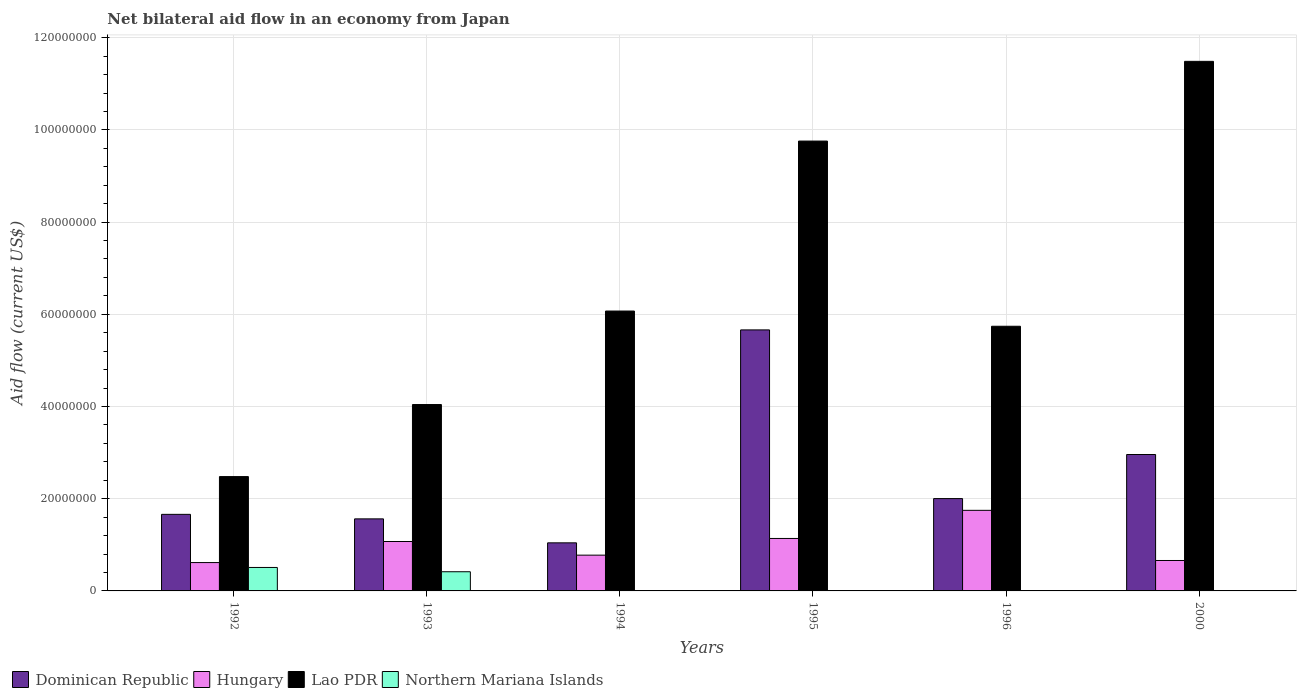How many different coloured bars are there?
Give a very brief answer. 4. How many groups of bars are there?
Ensure brevity in your answer.  6. Are the number of bars on each tick of the X-axis equal?
Ensure brevity in your answer.  No. In how many cases, is the number of bars for a given year not equal to the number of legend labels?
Your answer should be very brief. 2. Across all years, what is the maximum net bilateral aid flow in Northern Mariana Islands?
Ensure brevity in your answer.  5.09e+06. Across all years, what is the minimum net bilateral aid flow in Dominican Republic?
Ensure brevity in your answer.  1.04e+07. What is the total net bilateral aid flow in Northern Mariana Islands in the graph?
Provide a short and direct response. 9.27e+06. What is the difference between the net bilateral aid flow in Hungary in 1992 and that in 1995?
Ensure brevity in your answer.  -5.23e+06. What is the difference between the net bilateral aid flow in Lao PDR in 1994 and the net bilateral aid flow in Northern Mariana Islands in 1995?
Provide a short and direct response. 6.07e+07. What is the average net bilateral aid flow in Lao PDR per year?
Give a very brief answer. 6.60e+07. In the year 1993, what is the difference between the net bilateral aid flow in Lao PDR and net bilateral aid flow in Hungary?
Give a very brief answer. 2.97e+07. In how many years, is the net bilateral aid flow in Hungary greater than 80000000 US$?
Your answer should be very brief. 0. What is the ratio of the net bilateral aid flow in Dominican Republic in 1992 to that in 1993?
Keep it short and to the point. 1.06. Is the difference between the net bilateral aid flow in Lao PDR in 1993 and 1996 greater than the difference between the net bilateral aid flow in Hungary in 1993 and 1996?
Keep it short and to the point. No. What is the difference between the highest and the second highest net bilateral aid flow in Northern Mariana Islands?
Keep it short and to the point. 9.30e+05. What is the difference between the highest and the lowest net bilateral aid flow in Lao PDR?
Give a very brief answer. 9.01e+07. Is it the case that in every year, the sum of the net bilateral aid flow in Dominican Republic and net bilateral aid flow in Hungary is greater than the net bilateral aid flow in Lao PDR?
Provide a succinct answer. No. What is the difference between two consecutive major ticks on the Y-axis?
Provide a short and direct response. 2.00e+07. Are the values on the major ticks of Y-axis written in scientific E-notation?
Your answer should be compact. No. Does the graph contain any zero values?
Ensure brevity in your answer.  Yes. Does the graph contain grids?
Your answer should be very brief. Yes. Where does the legend appear in the graph?
Your answer should be compact. Bottom left. What is the title of the graph?
Give a very brief answer. Net bilateral aid flow in an economy from Japan. Does "Pakistan" appear as one of the legend labels in the graph?
Offer a terse response. No. What is the label or title of the X-axis?
Provide a succinct answer. Years. What is the label or title of the Y-axis?
Provide a short and direct response. Aid flow (current US$). What is the Aid flow (current US$) in Dominican Republic in 1992?
Your answer should be very brief. 1.66e+07. What is the Aid flow (current US$) in Hungary in 1992?
Give a very brief answer. 6.15e+06. What is the Aid flow (current US$) in Lao PDR in 1992?
Provide a succinct answer. 2.48e+07. What is the Aid flow (current US$) of Northern Mariana Islands in 1992?
Provide a short and direct response. 5.09e+06. What is the Aid flow (current US$) of Dominican Republic in 1993?
Give a very brief answer. 1.56e+07. What is the Aid flow (current US$) of Hungary in 1993?
Offer a very short reply. 1.07e+07. What is the Aid flow (current US$) of Lao PDR in 1993?
Give a very brief answer. 4.04e+07. What is the Aid flow (current US$) in Northern Mariana Islands in 1993?
Offer a very short reply. 4.16e+06. What is the Aid flow (current US$) in Dominican Republic in 1994?
Your answer should be very brief. 1.04e+07. What is the Aid flow (current US$) in Hungary in 1994?
Give a very brief answer. 7.76e+06. What is the Aid flow (current US$) of Lao PDR in 1994?
Provide a short and direct response. 6.07e+07. What is the Aid flow (current US$) of Dominican Republic in 1995?
Ensure brevity in your answer.  5.66e+07. What is the Aid flow (current US$) of Hungary in 1995?
Give a very brief answer. 1.14e+07. What is the Aid flow (current US$) of Lao PDR in 1995?
Offer a terse response. 9.76e+07. What is the Aid flow (current US$) in Dominican Republic in 1996?
Provide a short and direct response. 2.00e+07. What is the Aid flow (current US$) in Hungary in 1996?
Offer a terse response. 1.75e+07. What is the Aid flow (current US$) of Lao PDR in 1996?
Make the answer very short. 5.74e+07. What is the Aid flow (current US$) in Dominican Republic in 2000?
Your answer should be compact. 2.96e+07. What is the Aid flow (current US$) of Hungary in 2000?
Provide a short and direct response. 6.60e+06. What is the Aid flow (current US$) of Lao PDR in 2000?
Offer a terse response. 1.15e+08. What is the Aid flow (current US$) in Northern Mariana Islands in 2000?
Give a very brief answer. 10000. Across all years, what is the maximum Aid flow (current US$) in Dominican Republic?
Provide a short and direct response. 5.66e+07. Across all years, what is the maximum Aid flow (current US$) in Hungary?
Keep it short and to the point. 1.75e+07. Across all years, what is the maximum Aid flow (current US$) of Lao PDR?
Offer a terse response. 1.15e+08. Across all years, what is the maximum Aid flow (current US$) of Northern Mariana Islands?
Give a very brief answer. 5.09e+06. Across all years, what is the minimum Aid flow (current US$) of Dominican Republic?
Your answer should be very brief. 1.04e+07. Across all years, what is the minimum Aid flow (current US$) of Hungary?
Keep it short and to the point. 6.15e+06. Across all years, what is the minimum Aid flow (current US$) of Lao PDR?
Offer a very short reply. 2.48e+07. Across all years, what is the minimum Aid flow (current US$) in Northern Mariana Islands?
Your answer should be compact. 0. What is the total Aid flow (current US$) in Dominican Republic in the graph?
Provide a short and direct response. 1.49e+08. What is the total Aid flow (current US$) of Hungary in the graph?
Ensure brevity in your answer.  6.01e+07. What is the total Aid flow (current US$) in Lao PDR in the graph?
Offer a terse response. 3.96e+08. What is the total Aid flow (current US$) of Northern Mariana Islands in the graph?
Offer a very short reply. 9.27e+06. What is the difference between the Aid flow (current US$) in Dominican Republic in 1992 and that in 1993?
Ensure brevity in your answer.  9.80e+05. What is the difference between the Aid flow (current US$) of Hungary in 1992 and that in 1993?
Provide a short and direct response. -4.57e+06. What is the difference between the Aid flow (current US$) in Lao PDR in 1992 and that in 1993?
Keep it short and to the point. -1.56e+07. What is the difference between the Aid flow (current US$) in Northern Mariana Islands in 1992 and that in 1993?
Make the answer very short. 9.30e+05. What is the difference between the Aid flow (current US$) in Dominican Republic in 1992 and that in 1994?
Provide a short and direct response. 6.18e+06. What is the difference between the Aid flow (current US$) of Hungary in 1992 and that in 1994?
Provide a short and direct response. -1.61e+06. What is the difference between the Aid flow (current US$) in Lao PDR in 1992 and that in 1994?
Your response must be concise. -3.59e+07. What is the difference between the Aid flow (current US$) in Northern Mariana Islands in 1992 and that in 1994?
Provide a short and direct response. 5.08e+06. What is the difference between the Aid flow (current US$) in Dominican Republic in 1992 and that in 1995?
Offer a terse response. -4.00e+07. What is the difference between the Aid flow (current US$) in Hungary in 1992 and that in 1995?
Keep it short and to the point. -5.23e+06. What is the difference between the Aid flow (current US$) in Lao PDR in 1992 and that in 1995?
Your answer should be compact. -7.28e+07. What is the difference between the Aid flow (current US$) of Dominican Republic in 1992 and that in 1996?
Keep it short and to the point. -3.42e+06. What is the difference between the Aid flow (current US$) in Hungary in 1992 and that in 1996?
Provide a succinct answer. -1.13e+07. What is the difference between the Aid flow (current US$) of Lao PDR in 1992 and that in 1996?
Provide a succinct answer. -3.26e+07. What is the difference between the Aid flow (current US$) of Dominican Republic in 1992 and that in 2000?
Ensure brevity in your answer.  -1.30e+07. What is the difference between the Aid flow (current US$) in Hungary in 1992 and that in 2000?
Offer a very short reply. -4.50e+05. What is the difference between the Aid flow (current US$) in Lao PDR in 1992 and that in 2000?
Make the answer very short. -9.01e+07. What is the difference between the Aid flow (current US$) in Northern Mariana Islands in 1992 and that in 2000?
Ensure brevity in your answer.  5.08e+06. What is the difference between the Aid flow (current US$) in Dominican Republic in 1993 and that in 1994?
Provide a short and direct response. 5.20e+06. What is the difference between the Aid flow (current US$) of Hungary in 1993 and that in 1994?
Offer a terse response. 2.96e+06. What is the difference between the Aid flow (current US$) in Lao PDR in 1993 and that in 1994?
Offer a terse response. -2.03e+07. What is the difference between the Aid flow (current US$) in Northern Mariana Islands in 1993 and that in 1994?
Make the answer very short. 4.15e+06. What is the difference between the Aid flow (current US$) in Dominican Republic in 1993 and that in 1995?
Your answer should be compact. -4.10e+07. What is the difference between the Aid flow (current US$) of Hungary in 1993 and that in 1995?
Provide a succinct answer. -6.60e+05. What is the difference between the Aid flow (current US$) in Lao PDR in 1993 and that in 1995?
Make the answer very short. -5.72e+07. What is the difference between the Aid flow (current US$) in Dominican Republic in 1993 and that in 1996?
Provide a short and direct response. -4.40e+06. What is the difference between the Aid flow (current US$) of Hungary in 1993 and that in 1996?
Ensure brevity in your answer.  -6.76e+06. What is the difference between the Aid flow (current US$) in Lao PDR in 1993 and that in 1996?
Your answer should be compact. -1.70e+07. What is the difference between the Aid flow (current US$) of Dominican Republic in 1993 and that in 2000?
Provide a short and direct response. -1.40e+07. What is the difference between the Aid flow (current US$) in Hungary in 1993 and that in 2000?
Your answer should be very brief. 4.12e+06. What is the difference between the Aid flow (current US$) of Lao PDR in 1993 and that in 2000?
Provide a short and direct response. -7.44e+07. What is the difference between the Aid flow (current US$) of Northern Mariana Islands in 1993 and that in 2000?
Make the answer very short. 4.15e+06. What is the difference between the Aid flow (current US$) in Dominican Republic in 1994 and that in 1995?
Offer a very short reply. -4.62e+07. What is the difference between the Aid flow (current US$) of Hungary in 1994 and that in 1995?
Provide a succinct answer. -3.62e+06. What is the difference between the Aid flow (current US$) in Lao PDR in 1994 and that in 1995?
Keep it short and to the point. -3.69e+07. What is the difference between the Aid flow (current US$) in Dominican Republic in 1994 and that in 1996?
Give a very brief answer. -9.60e+06. What is the difference between the Aid flow (current US$) of Hungary in 1994 and that in 1996?
Make the answer very short. -9.72e+06. What is the difference between the Aid flow (current US$) in Lao PDR in 1994 and that in 1996?
Provide a short and direct response. 3.30e+06. What is the difference between the Aid flow (current US$) of Dominican Republic in 1994 and that in 2000?
Offer a terse response. -1.92e+07. What is the difference between the Aid flow (current US$) in Hungary in 1994 and that in 2000?
Offer a very short reply. 1.16e+06. What is the difference between the Aid flow (current US$) of Lao PDR in 1994 and that in 2000?
Provide a short and direct response. -5.42e+07. What is the difference between the Aid flow (current US$) in Dominican Republic in 1995 and that in 1996?
Your response must be concise. 3.66e+07. What is the difference between the Aid flow (current US$) of Hungary in 1995 and that in 1996?
Your answer should be very brief. -6.10e+06. What is the difference between the Aid flow (current US$) in Lao PDR in 1995 and that in 1996?
Provide a short and direct response. 4.02e+07. What is the difference between the Aid flow (current US$) in Dominican Republic in 1995 and that in 2000?
Ensure brevity in your answer.  2.70e+07. What is the difference between the Aid flow (current US$) in Hungary in 1995 and that in 2000?
Provide a succinct answer. 4.78e+06. What is the difference between the Aid flow (current US$) of Lao PDR in 1995 and that in 2000?
Give a very brief answer. -1.73e+07. What is the difference between the Aid flow (current US$) in Dominican Republic in 1996 and that in 2000?
Offer a very short reply. -9.56e+06. What is the difference between the Aid flow (current US$) of Hungary in 1996 and that in 2000?
Your answer should be very brief. 1.09e+07. What is the difference between the Aid flow (current US$) of Lao PDR in 1996 and that in 2000?
Provide a succinct answer. -5.75e+07. What is the difference between the Aid flow (current US$) in Dominican Republic in 1992 and the Aid flow (current US$) in Hungary in 1993?
Keep it short and to the point. 5.89e+06. What is the difference between the Aid flow (current US$) of Dominican Republic in 1992 and the Aid flow (current US$) of Lao PDR in 1993?
Your answer should be compact. -2.38e+07. What is the difference between the Aid flow (current US$) in Dominican Republic in 1992 and the Aid flow (current US$) in Northern Mariana Islands in 1993?
Provide a succinct answer. 1.24e+07. What is the difference between the Aid flow (current US$) of Hungary in 1992 and the Aid flow (current US$) of Lao PDR in 1993?
Keep it short and to the point. -3.43e+07. What is the difference between the Aid flow (current US$) of Hungary in 1992 and the Aid flow (current US$) of Northern Mariana Islands in 1993?
Offer a very short reply. 1.99e+06. What is the difference between the Aid flow (current US$) of Lao PDR in 1992 and the Aid flow (current US$) of Northern Mariana Islands in 1993?
Offer a very short reply. 2.06e+07. What is the difference between the Aid flow (current US$) of Dominican Republic in 1992 and the Aid flow (current US$) of Hungary in 1994?
Make the answer very short. 8.85e+06. What is the difference between the Aid flow (current US$) of Dominican Republic in 1992 and the Aid flow (current US$) of Lao PDR in 1994?
Your answer should be very brief. -4.41e+07. What is the difference between the Aid flow (current US$) in Dominican Republic in 1992 and the Aid flow (current US$) in Northern Mariana Islands in 1994?
Make the answer very short. 1.66e+07. What is the difference between the Aid flow (current US$) of Hungary in 1992 and the Aid flow (current US$) of Lao PDR in 1994?
Give a very brief answer. -5.46e+07. What is the difference between the Aid flow (current US$) of Hungary in 1992 and the Aid flow (current US$) of Northern Mariana Islands in 1994?
Offer a terse response. 6.14e+06. What is the difference between the Aid flow (current US$) in Lao PDR in 1992 and the Aid flow (current US$) in Northern Mariana Islands in 1994?
Give a very brief answer. 2.48e+07. What is the difference between the Aid flow (current US$) in Dominican Republic in 1992 and the Aid flow (current US$) in Hungary in 1995?
Your answer should be compact. 5.23e+06. What is the difference between the Aid flow (current US$) in Dominican Republic in 1992 and the Aid flow (current US$) in Lao PDR in 1995?
Give a very brief answer. -8.10e+07. What is the difference between the Aid flow (current US$) in Hungary in 1992 and the Aid flow (current US$) in Lao PDR in 1995?
Keep it short and to the point. -9.14e+07. What is the difference between the Aid flow (current US$) of Dominican Republic in 1992 and the Aid flow (current US$) of Hungary in 1996?
Offer a terse response. -8.70e+05. What is the difference between the Aid flow (current US$) in Dominican Republic in 1992 and the Aid flow (current US$) in Lao PDR in 1996?
Ensure brevity in your answer.  -4.08e+07. What is the difference between the Aid flow (current US$) of Hungary in 1992 and the Aid flow (current US$) of Lao PDR in 1996?
Offer a terse response. -5.13e+07. What is the difference between the Aid flow (current US$) of Dominican Republic in 1992 and the Aid flow (current US$) of Hungary in 2000?
Your response must be concise. 1.00e+07. What is the difference between the Aid flow (current US$) of Dominican Republic in 1992 and the Aid flow (current US$) of Lao PDR in 2000?
Give a very brief answer. -9.83e+07. What is the difference between the Aid flow (current US$) in Dominican Republic in 1992 and the Aid flow (current US$) in Northern Mariana Islands in 2000?
Give a very brief answer. 1.66e+07. What is the difference between the Aid flow (current US$) of Hungary in 1992 and the Aid flow (current US$) of Lao PDR in 2000?
Give a very brief answer. -1.09e+08. What is the difference between the Aid flow (current US$) in Hungary in 1992 and the Aid flow (current US$) in Northern Mariana Islands in 2000?
Ensure brevity in your answer.  6.14e+06. What is the difference between the Aid flow (current US$) of Lao PDR in 1992 and the Aid flow (current US$) of Northern Mariana Islands in 2000?
Your answer should be compact. 2.48e+07. What is the difference between the Aid flow (current US$) of Dominican Republic in 1993 and the Aid flow (current US$) of Hungary in 1994?
Offer a very short reply. 7.87e+06. What is the difference between the Aid flow (current US$) of Dominican Republic in 1993 and the Aid flow (current US$) of Lao PDR in 1994?
Your answer should be compact. -4.51e+07. What is the difference between the Aid flow (current US$) in Dominican Republic in 1993 and the Aid flow (current US$) in Northern Mariana Islands in 1994?
Your response must be concise. 1.56e+07. What is the difference between the Aid flow (current US$) in Hungary in 1993 and the Aid flow (current US$) in Lao PDR in 1994?
Your response must be concise. -5.00e+07. What is the difference between the Aid flow (current US$) of Hungary in 1993 and the Aid flow (current US$) of Northern Mariana Islands in 1994?
Make the answer very short. 1.07e+07. What is the difference between the Aid flow (current US$) in Lao PDR in 1993 and the Aid flow (current US$) in Northern Mariana Islands in 1994?
Provide a short and direct response. 4.04e+07. What is the difference between the Aid flow (current US$) of Dominican Republic in 1993 and the Aid flow (current US$) of Hungary in 1995?
Make the answer very short. 4.25e+06. What is the difference between the Aid flow (current US$) of Dominican Republic in 1993 and the Aid flow (current US$) of Lao PDR in 1995?
Your answer should be very brief. -8.20e+07. What is the difference between the Aid flow (current US$) of Hungary in 1993 and the Aid flow (current US$) of Lao PDR in 1995?
Ensure brevity in your answer.  -8.69e+07. What is the difference between the Aid flow (current US$) in Dominican Republic in 1993 and the Aid flow (current US$) in Hungary in 1996?
Offer a very short reply. -1.85e+06. What is the difference between the Aid flow (current US$) of Dominican Republic in 1993 and the Aid flow (current US$) of Lao PDR in 1996?
Provide a short and direct response. -4.18e+07. What is the difference between the Aid flow (current US$) of Hungary in 1993 and the Aid flow (current US$) of Lao PDR in 1996?
Your answer should be compact. -4.67e+07. What is the difference between the Aid flow (current US$) of Dominican Republic in 1993 and the Aid flow (current US$) of Hungary in 2000?
Your answer should be compact. 9.03e+06. What is the difference between the Aid flow (current US$) in Dominican Republic in 1993 and the Aid flow (current US$) in Lao PDR in 2000?
Your answer should be very brief. -9.92e+07. What is the difference between the Aid flow (current US$) in Dominican Republic in 1993 and the Aid flow (current US$) in Northern Mariana Islands in 2000?
Offer a very short reply. 1.56e+07. What is the difference between the Aid flow (current US$) of Hungary in 1993 and the Aid flow (current US$) of Lao PDR in 2000?
Provide a short and direct response. -1.04e+08. What is the difference between the Aid flow (current US$) of Hungary in 1993 and the Aid flow (current US$) of Northern Mariana Islands in 2000?
Offer a very short reply. 1.07e+07. What is the difference between the Aid flow (current US$) of Lao PDR in 1993 and the Aid flow (current US$) of Northern Mariana Islands in 2000?
Provide a short and direct response. 4.04e+07. What is the difference between the Aid flow (current US$) of Dominican Republic in 1994 and the Aid flow (current US$) of Hungary in 1995?
Your answer should be compact. -9.50e+05. What is the difference between the Aid flow (current US$) of Dominican Republic in 1994 and the Aid flow (current US$) of Lao PDR in 1995?
Keep it short and to the point. -8.72e+07. What is the difference between the Aid flow (current US$) of Hungary in 1994 and the Aid flow (current US$) of Lao PDR in 1995?
Make the answer very short. -8.98e+07. What is the difference between the Aid flow (current US$) of Dominican Republic in 1994 and the Aid flow (current US$) of Hungary in 1996?
Keep it short and to the point. -7.05e+06. What is the difference between the Aid flow (current US$) in Dominican Republic in 1994 and the Aid flow (current US$) in Lao PDR in 1996?
Ensure brevity in your answer.  -4.70e+07. What is the difference between the Aid flow (current US$) in Hungary in 1994 and the Aid flow (current US$) in Lao PDR in 1996?
Offer a very short reply. -4.96e+07. What is the difference between the Aid flow (current US$) of Dominican Republic in 1994 and the Aid flow (current US$) of Hungary in 2000?
Provide a short and direct response. 3.83e+06. What is the difference between the Aid flow (current US$) in Dominican Republic in 1994 and the Aid flow (current US$) in Lao PDR in 2000?
Your answer should be compact. -1.04e+08. What is the difference between the Aid flow (current US$) in Dominican Republic in 1994 and the Aid flow (current US$) in Northern Mariana Islands in 2000?
Offer a terse response. 1.04e+07. What is the difference between the Aid flow (current US$) in Hungary in 1994 and the Aid flow (current US$) in Lao PDR in 2000?
Your answer should be compact. -1.07e+08. What is the difference between the Aid flow (current US$) in Hungary in 1994 and the Aid flow (current US$) in Northern Mariana Islands in 2000?
Keep it short and to the point. 7.75e+06. What is the difference between the Aid flow (current US$) in Lao PDR in 1994 and the Aid flow (current US$) in Northern Mariana Islands in 2000?
Provide a succinct answer. 6.07e+07. What is the difference between the Aid flow (current US$) in Dominican Republic in 1995 and the Aid flow (current US$) in Hungary in 1996?
Offer a terse response. 3.91e+07. What is the difference between the Aid flow (current US$) in Dominican Republic in 1995 and the Aid flow (current US$) in Lao PDR in 1996?
Give a very brief answer. -7.90e+05. What is the difference between the Aid flow (current US$) in Hungary in 1995 and the Aid flow (current US$) in Lao PDR in 1996?
Offer a very short reply. -4.60e+07. What is the difference between the Aid flow (current US$) in Dominican Republic in 1995 and the Aid flow (current US$) in Hungary in 2000?
Offer a terse response. 5.00e+07. What is the difference between the Aid flow (current US$) in Dominican Republic in 1995 and the Aid flow (current US$) in Lao PDR in 2000?
Provide a short and direct response. -5.82e+07. What is the difference between the Aid flow (current US$) of Dominican Republic in 1995 and the Aid flow (current US$) of Northern Mariana Islands in 2000?
Keep it short and to the point. 5.66e+07. What is the difference between the Aid flow (current US$) in Hungary in 1995 and the Aid flow (current US$) in Lao PDR in 2000?
Your answer should be very brief. -1.03e+08. What is the difference between the Aid flow (current US$) in Hungary in 1995 and the Aid flow (current US$) in Northern Mariana Islands in 2000?
Your answer should be compact. 1.14e+07. What is the difference between the Aid flow (current US$) in Lao PDR in 1995 and the Aid flow (current US$) in Northern Mariana Islands in 2000?
Your answer should be very brief. 9.76e+07. What is the difference between the Aid flow (current US$) in Dominican Republic in 1996 and the Aid flow (current US$) in Hungary in 2000?
Offer a very short reply. 1.34e+07. What is the difference between the Aid flow (current US$) in Dominican Republic in 1996 and the Aid flow (current US$) in Lao PDR in 2000?
Your answer should be very brief. -9.48e+07. What is the difference between the Aid flow (current US$) of Dominican Republic in 1996 and the Aid flow (current US$) of Northern Mariana Islands in 2000?
Your answer should be compact. 2.00e+07. What is the difference between the Aid flow (current US$) in Hungary in 1996 and the Aid flow (current US$) in Lao PDR in 2000?
Provide a short and direct response. -9.74e+07. What is the difference between the Aid flow (current US$) in Hungary in 1996 and the Aid flow (current US$) in Northern Mariana Islands in 2000?
Give a very brief answer. 1.75e+07. What is the difference between the Aid flow (current US$) in Lao PDR in 1996 and the Aid flow (current US$) in Northern Mariana Islands in 2000?
Ensure brevity in your answer.  5.74e+07. What is the average Aid flow (current US$) in Dominican Republic per year?
Give a very brief answer. 2.48e+07. What is the average Aid flow (current US$) in Hungary per year?
Offer a terse response. 1.00e+07. What is the average Aid flow (current US$) in Lao PDR per year?
Offer a very short reply. 6.60e+07. What is the average Aid flow (current US$) of Northern Mariana Islands per year?
Provide a succinct answer. 1.54e+06. In the year 1992, what is the difference between the Aid flow (current US$) in Dominican Republic and Aid flow (current US$) in Hungary?
Ensure brevity in your answer.  1.05e+07. In the year 1992, what is the difference between the Aid flow (current US$) of Dominican Republic and Aid flow (current US$) of Lao PDR?
Ensure brevity in your answer.  -8.19e+06. In the year 1992, what is the difference between the Aid flow (current US$) in Dominican Republic and Aid flow (current US$) in Northern Mariana Islands?
Your response must be concise. 1.15e+07. In the year 1992, what is the difference between the Aid flow (current US$) in Hungary and Aid flow (current US$) in Lao PDR?
Give a very brief answer. -1.86e+07. In the year 1992, what is the difference between the Aid flow (current US$) in Hungary and Aid flow (current US$) in Northern Mariana Islands?
Offer a very short reply. 1.06e+06. In the year 1992, what is the difference between the Aid flow (current US$) of Lao PDR and Aid flow (current US$) of Northern Mariana Islands?
Keep it short and to the point. 1.97e+07. In the year 1993, what is the difference between the Aid flow (current US$) in Dominican Republic and Aid flow (current US$) in Hungary?
Your answer should be very brief. 4.91e+06. In the year 1993, what is the difference between the Aid flow (current US$) in Dominican Republic and Aid flow (current US$) in Lao PDR?
Give a very brief answer. -2.48e+07. In the year 1993, what is the difference between the Aid flow (current US$) in Dominican Republic and Aid flow (current US$) in Northern Mariana Islands?
Provide a succinct answer. 1.15e+07. In the year 1993, what is the difference between the Aid flow (current US$) of Hungary and Aid flow (current US$) of Lao PDR?
Your answer should be very brief. -2.97e+07. In the year 1993, what is the difference between the Aid flow (current US$) of Hungary and Aid flow (current US$) of Northern Mariana Islands?
Provide a succinct answer. 6.56e+06. In the year 1993, what is the difference between the Aid flow (current US$) of Lao PDR and Aid flow (current US$) of Northern Mariana Islands?
Ensure brevity in your answer.  3.63e+07. In the year 1994, what is the difference between the Aid flow (current US$) in Dominican Republic and Aid flow (current US$) in Hungary?
Ensure brevity in your answer.  2.67e+06. In the year 1994, what is the difference between the Aid flow (current US$) in Dominican Republic and Aid flow (current US$) in Lao PDR?
Provide a short and direct response. -5.03e+07. In the year 1994, what is the difference between the Aid flow (current US$) of Dominican Republic and Aid flow (current US$) of Northern Mariana Islands?
Provide a succinct answer. 1.04e+07. In the year 1994, what is the difference between the Aid flow (current US$) in Hungary and Aid flow (current US$) in Lao PDR?
Your answer should be very brief. -5.30e+07. In the year 1994, what is the difference between the Aid flow (current US$) of Hungary and Aid flow (current US$) of Northern Mariana Islands?
Make the answer very short. 7.75e+06. In the year 1994, what is the difference between the Aid flow (current US$) in Lao PDR and Aid flow (current US$) in Northern Mariana Islands?
Make the answer very short. 6.07e+07. In the year 1995, what is the difference between the Aid flow (current US$) of Dominican Republic and Aid flow (current US$) of Hungary?
Offer a very short reply. 4.52e+07. In the year 1995, what is the difference between the Aid flow (current US$) of Dominican Republic and Aid flow (current US$) of Lao PDR?
Your answer should be very brief. -4.10e+07. In the year 1995, what is the difference between the Aid flow (current US$) in Hungary and Aid flow (current US$) in Lao PDR?
Give a very brief answer. -8.62e+07. In the year 1996, what is the difference between the Aid flow (current US$) of Dominican Republic and Aid flow (current US$) of Hungary?
Give a very brief answer. 2.55e+06. In the year 1996, what is the difference between the Aid flow (current US$) in Dominican Republic and Aid flow (current US$) in Lao PDR?
Your answer should be very brief. -3.74e+07. In the year 1996, what is the difference between the Aid flow (current US$) in Hungary and Aid flow (current US$) in Lao PDR?
Your answer should be compact. -3.99e+07. In the year 2000, what is the difference between the Aid flow (current US$) of Dominican Republic and Aid flow (current US$) of Hungary?
Provide a short and direct response. 2.30e+07. In the year 2000, what is the difference between the Aid flow (current US$) of Dominican Republic and Aid flow (current US$) of Lao PDR?
Your response must be concise. -8.53e+07. In the year 2000, what is the difference between the Aid flow (current US$) in Dominican Republic and Aid flow (current US$) in Northern Mariana Islands?
Provide a short and direct response. 2.96e+07. In the year 2000, what is the difference between the Aid flow (current US$) in Hungary and Aid flow (current US$) in Lao PDR?
Provide a succinct answer. -1.08e+08. In the year 2000, what is the difference between the Aid flow (current US$) in Hungary and Aid flow (current US$) in Northern Mariana Islands?
Provide a succinct answer. 6.59e+06. In the year 2000, what is the difference between the Aid flow (current US$) of Lao PDR and Aid flow (current US$) of Northern Mariana Islands?
Your answer should be very brief. 1.15e+08. What is the ratio of the Aid flow (current US$) of Dominican Republic in 1992 to that in 1993?
Your answer should be very brief. 1.06. What is the ratio of the Aid flow (current US$) in Hungary in 1992 to that in 1993?
Offer a very short reply. 0.57. What is the ratio of the Aid flow (current US$) in Lao PDR in 1992 to that in 1993?
Offer a terse response. 0.61. What is the ratio of the Aid flow (current US$) in Northern Mariana Islands in 1992 to that in 1993?
Your response must be concise. 1.22. What is the ratio of the Aid flow (current US$) in Dominican Republic in 1992 to that in 1994?
Your response must be concise. 1.59. What is the ratio of the Aid flow (current US$) of Hungary in 1992 to that in 1994?
Your answer should be compact. 0.79. What is the ratio of the Aid flow (current US$) of Lao PDR in 1992 to that in 1994?
Offer a very short reply. 0.41. What is the ratio of the Aid flow (current US$) in Northern Mariana Islands in 1992 to that in 1994?
Offer a very short reply. 509. What is the ratio of the Aid flow (current US$) of Dominican Republic in 1992 to that in 1995?
Ensure brevity in your answer.  0.29. What is the ratio of the Aid flow (current US$) of Hungary in 1992 to that in 1995?
Ensure brevity in your answer.  0.54. What is the ratio of the Aid flow (current US$) in Lao PDR in 1992 to that in 1995?
Offer a very short reply. 0.25. What is the ratio of the Aid flow (current US$) in Dominican Republic in 1992 to that in 1996?
Give a very brief answer. 0.83. What is the ratio of the Aid flow (current US$) in Hungary in 1992 to that in 1996?
Provide a short and direct response. 0.35. What is the ratio of the Aid flow (current US$) in Lao PDR in 1992 to that in 1996?
Offer a terse response. 0.43. What is the ratio of the Aid flow (current US$) of Dominican Republic in 1992 to that in 2000?
Make the answer very short. 0.56. What is the ratio of the Aid flow (current US$) of Hungary in 1992 to that in 2000?
Provide a short and direct response. 0.93. What is the ratio of the Aid flow (current US$) in Lao PDR in 1992 to that in 2000?
Your answer should be compact. 0.22. What is the ratio of the Aid flow (current US$) of Northern Mariana Islands in 1992 to that in 2000?
Offer a very short reply. 509. What is the ratio of the Aid flow (current US$) of Dominican Republic in 1993 to that in 1994?
Your response must be concise. 1.5. What is the ratio of the Aid flow (current US$) of Hungary in 1993 to that in 1994?
Your answer should be compact. 1.38. What is the ratio of the Aid flow (current US$) of Lao PDR in 1993 to that in 1994?
Your response must be concise. 0.67. What is the ratio of the Aid flow (current US$) in Northern Mariana Islands in 1993 to that in 1994?
Offer a very short reply. 416. What is the ratio of the Aid flow (current US$) of Dominican Republic in 1993 to that in 1995?
Ensure brevity in your answer.  0.28. What is the ratio of the Aid flow (current US$) of Hungary in 1993 to that in 1995?
Provide a short and direct response. 0.94. What is the ratio of the Aid flow (current US$) in Lao PDR in 1993 to that in 1995?
Offer a very short reply. 0.41. What is the ratio of the Aid flow (current US$) in Dominican Republic in 1993 to that in 1996?
Provide a short and direct response. 0.78. What is the ratio of the Aid flow (current US$) of Hungary in 1993 to that in 1996?
Keep it short and to the point. 0.61. What is the ratio of the Aid flow (current US$) in Lao PDR in 1993 to that in 1996?
Keep it short and to the point. 0.7. What is the ratio of the Aid flow (current US$) of Dominican Republic in 1993 to that in 2000?
Offer a very short reply. 0.53. What is the ratio of the Aid flow (current US$) of Hungary in 1993 to that in 2000?
Provide a short and direct response. 1.62. What is the ratio of the Aid flow (current US$) of Lao PDR in 1993 to that in 2000?
Provide a succinct answer. 0.35. What is the ratio of the Aid flow (current US$) in Northern Mariana Islands in 1993 to that in 2000?
Your answer should be very brief. 416. What is the ratio of the Aid flow (current US$) in Dominican Republic in 1994 to that in 1995?
Your answer should be very brief. 0.18. What is the ratio of the Aid flow (current US$) of Hungary in 1994 to that in 1995?
Make the answer very short. 0.68. What is the ratio of the Aid flow (current US$) of Lao PDR in 1994 to that in 1995?
Your answer should be compact. 0.62. What is the ratio of the Aid flow (current US$) of Dominican Republic in 1994 to that in 1996?
Make the answer very short. 0.52. What is the ratio of the Aid flow (current US$) in Hungary in 1994 to that in 1996?
Offer a terse response. 0.44. What is the ratio of the Aid flow (current US$) in Lao PDR in 1994 to that in 1996?
Offer a very short reply. 1.06. What is the ratio of the Aid flow (current US$) in Dominican Republic in 1994 to that in 2000?
Offer a very short reply. 0.35. What is the ratio of the Aid flow (current US$) of Hungary in 1994 to that in 2000?
Give a very brief answer. 1.18. What is the ratio of the Aid flow (current US$) in Lao PDR in 1994 to that in 2000?
Give a very brief answer. 0.53. What is the ratio of the Aid flow (current US$) in Northern Mariana Islands in 1994 to that in 2000?
Make the answer very short. 1. What is the ratio of the Aid flow (current US$) in Dominican Republic in 1995 to that in 1996?
Provide a succinct answer. 2.83. What is the ratio of the Aid flow (current US$) of Hungary in 1995 to that in 1996?
Your answer should be compact. 0.65. What is the ratio of the Aid flow (current US$) in Lao PDR in 1995 to that in 1996?
Keep it short and to the point. 1.7. What is the ratio of the Aid flow (current US$) in Dominican Republic in 1995 to that in 2000?
Your response must be concise. 1.91. What is the ratio of the Aid flow (current US$) in Hungary in 1995 to that in 2000?
Provide a short and direct response. 1.72. What is the ratio of the Aid flow (current US$) in Lao PDR in 1995 to that in 2000?
Provide a succinct answer. 0.85. What is the ratio of the Aid flow (current US$) of Dominican Republic in 1996 to that in 2000?
Your answer should be compact. 0.68. What is the ratio of the Aid flow (current US$) of Hungary in 1996 to that in 2000?
Offer a terse response. 2.65. What is the ratio of the Aid flow (current US$) in Lao PDR in 1996 to that in 2000?
Ensure brevity in your answer.  0.5. What is the difference between the highest and the second highest Aid flow (current US$) of Dominican Republic?
Keep it short and to the point. 2.70e+07. What is the difference between the highest and the second highest Aid flow (current US$) in Hungary?
Provide a succinct answer. 6.10e+06. What is the difference between the highest and the second highest Aid flow (current US$) of Lao PDR?
Ensure brevity in your answer.  1.73e+07. What is the difference between the highest and the second highest Aid flow (current US$) of Northern Mariana Islands?
Your response must be concise. 9.30e+05. What is the difference between the highest and the lowest Aid flow (current US$) of Dominican Republic?
Your answer should be very brief. 4.62e+07. What is the difference between the highest and the lowest Aid flow (current US$) in Hungary?
Ensure brevity in your answer.  1.13e+07. What is the difference between the highest and the lowest Aid flow (current US$) of Lao PDR?
Your answer should be very brief. 9.01e+07. What is the difference between the highest and the lowest Aid flow (current US$) in Northern Mariana Islands?
Give a very brief answer. 5.09e+06. 